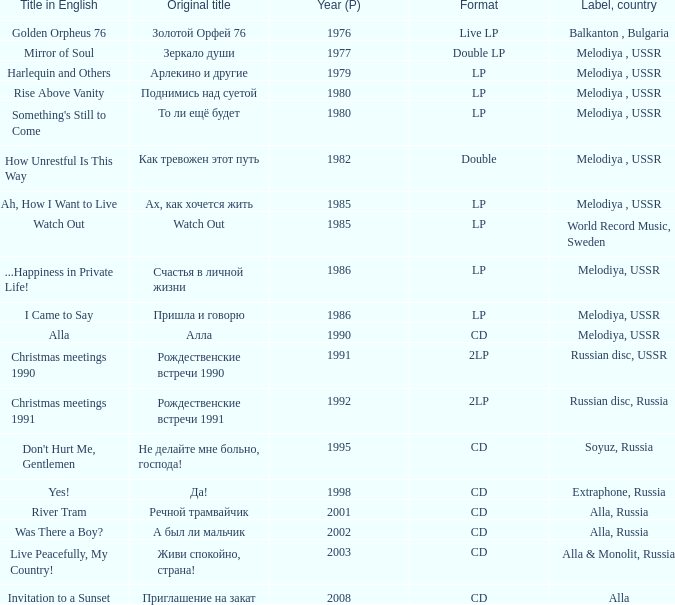What is the english title with a lp format and an Original title of то ли ещё будет? Something's Still to Come. 